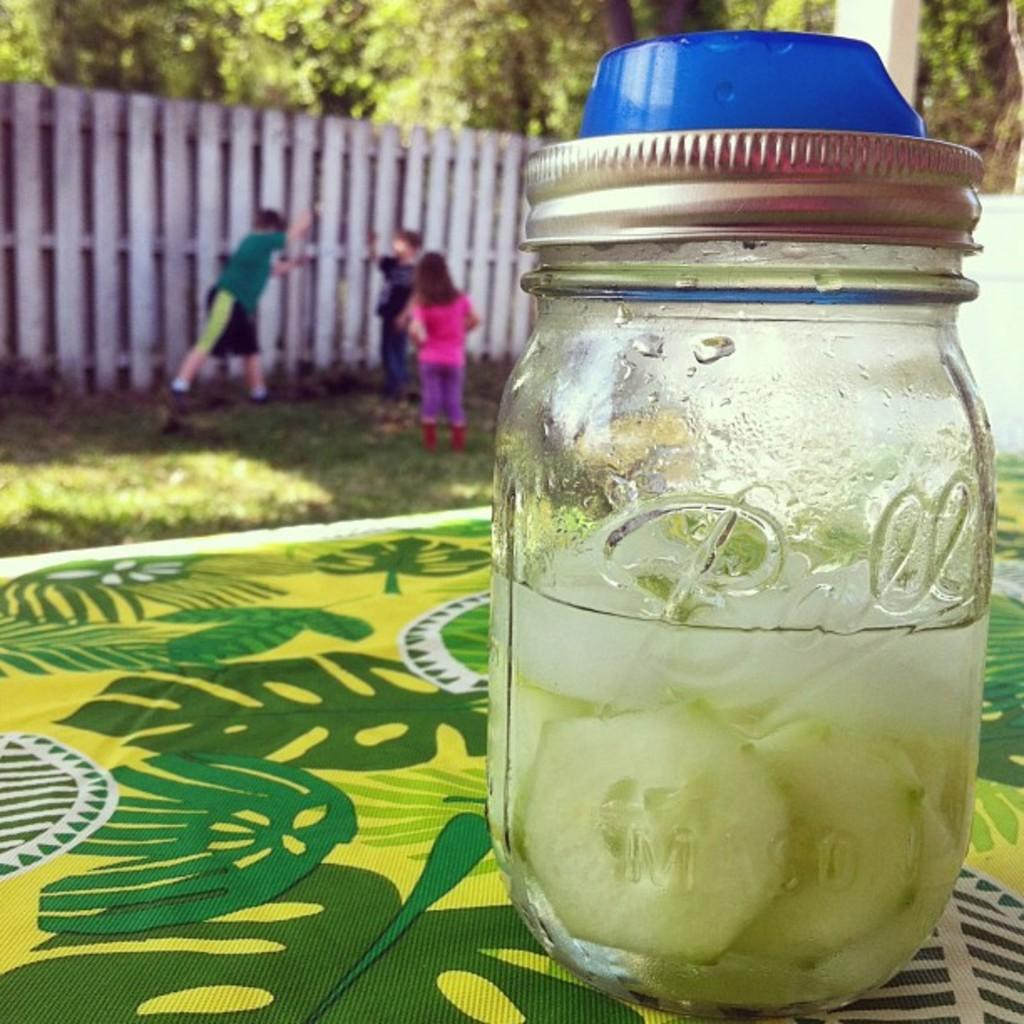What type of vegetable can be seen in the image? There are cucumbers in the image. What is contained in the jar that is visible in the image? There is water in a jar in the image. Where is the jar placed in the image? The jar is placed on a table. What can be seen in the background of the image? There is fencing, persons, grass, and trees in the background of the image. What type of beginner's tool is being used to open the jar in the image? There is no tool visible in the image, and the jar is already open, containing water. Can you tell me how many crackers are on the table in the image? There are no crackers present in the image; it features cucumbers, a jar of water, and a table. What color is the button on the cucumber in the image? There is no button on the cucumber in the image; it is a vegetable with a natural appearance. 